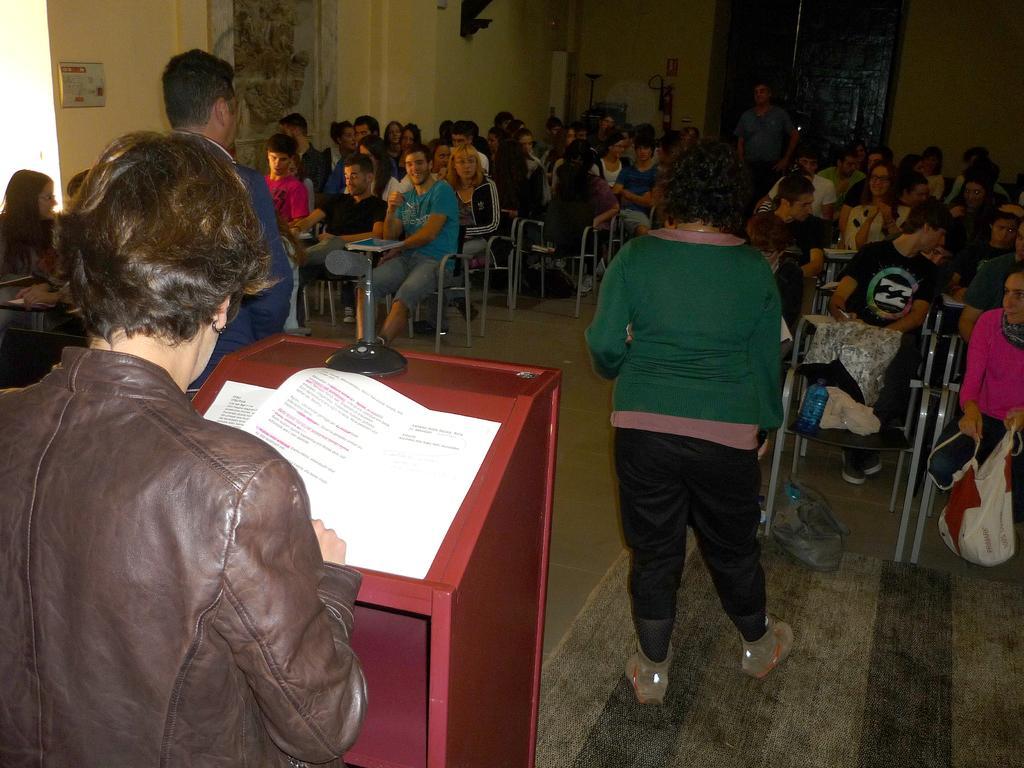How would you summarize this image in a sentence or two? In this image we can see there is a person standing in front of the table. On the table there is a mic and few papers. In front of the table there are two persons standing and few people are sitting on the chairs. In the background there is a wall and a closed door. 